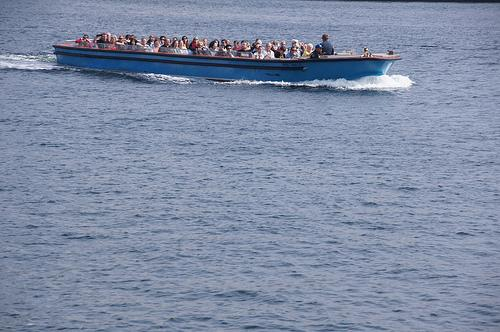Describe the waves made by the boat and their impact on the water. The boat creates small ripples and a wake coming off the back, forming white froth and foam on the calm water. What is the main focus in this image, and what kind of task could be relevant for it? The main focus is on the long blue boat with people in it, making it suitable for object detection and object interaction analysis tasks. What is the main action happening in the image, and who or what is causing it? A long blue boat filled with people is floating on a body of water, causing small ripples and white waves. Mention any specific activity you can observe people doing on the boat. A person at the front of the boat is wearing a hat, and another person seems to be taking a picture. Identify three features or characteristics of the boat and its surroundings. The boat has a sharp front, thin dark blue line on its side, and a short glass shield at the lip edge. Count how many people are visible in the image and describe their position within the boat. There are multiple people on this boat, with some at the front, others in the middle, and a person sitting in the very back. Analyze the interaction between the boat and the water in the image. The boat is floating smoothly on the calm water, causing small ripples, white waves, and foamy wake behind it. Point out the color of the boat and the condition of the water in the image. The boat is blue and the water is calm with only very small ripples. Describe the overall sentiment or mood of the image. The image has a relaxed and peaceful mood since the people are sitting on a boat, enjoying their time on the calm water. In the context of image sentiment analysis, how would you rate the quality of this image? The image presents a clear scene of people on a boat and conveys a peaceful mood, so the quality can be rated as high. Does the boat have a green stripe on it? The captions mention a thin dark blue line, thin black line, and blue paint on the side of the boat, but there is no mention of a green stripe. Is there a person standing up and waving on the boat? The captions describe people as sitting and a person taking a picture, but there is no mention of someone standing up and waving. Is there a red boat in the image? There is no mention of a red boat in the provided captions. The boat is described as blue and long, but not red. Are there any large, tall waves in the water? The captions describe the water as calm, with small ripples, and waves. There is no mention of large or tall waves. Can you spot a dog on the boat? The captions mention people (humans) on the boat, but there is no mention of any animals like a dog. Can you find a person wearing a yellow hat on the boat? There is no mention of a person wearing a yellow hat in the provided captions. There is a person with a blue baseball cap mentioned, but not a yellow one. 